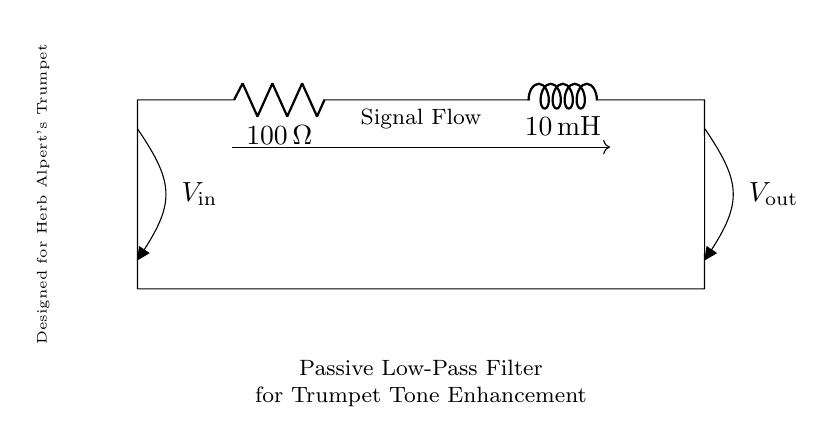What is the resistance value in this circuit? The resistance value is labeled in the circuit diagram as 100 ohms, indicating the resistance component in this passive low-pass filter.
Answer: 100 ohm What is the inductance value in this circuit? The inductance value is labeled in the circuit diagram as 10 millihenries, which refers to the inductor in the passive low-pass filter.
Answer: 10 millihenry What type of filter is represented by this circuit? The circuit includes a combination of a resistor and an inductor, which together serve as a passive low-pass filter to allow lower frequencies to pass through while attenuating higher frequencies.
Answer: Low-pass filter What is the purpose of this circuit in relation to trumpet tones? The purpose stated in the circuit diagram is to enhance trumpet tones, implying that the filter is designed to improve the audio quality and richness of the sound produced by a trumpet, particularly for applications related to players like Herb Alpert.
Answer: Enhance trumpet tones How does the frequency of the input signal affect the output voltage? In a passive low-pass filter, as the frequency of the input signal increases, the output voltage decreases due to the reactance of the inductor increasing, which limits the higher frequency signals more than lower ones.
Answer: Output voltage decreases with increasing frequency Why does this circuit include both a resistor and an inductor? The combination of a resistor and an inductor in the circuit helps achieve a desired impedance and frequency response characteristic, which is essential for shaping audio signals in ways that improve quality—specifically, low frequencies are allowed to pass while high frequencies are attenuated.
Answer: To shape audio signals What does V out represent in this diagram? V out is labeled in the circuit diagram as the output voltage, which measures the voltage across the output terminals after the audio signal has passed through the low-pass filter, reflecting the filtered sound.
Answer: Output voltage 